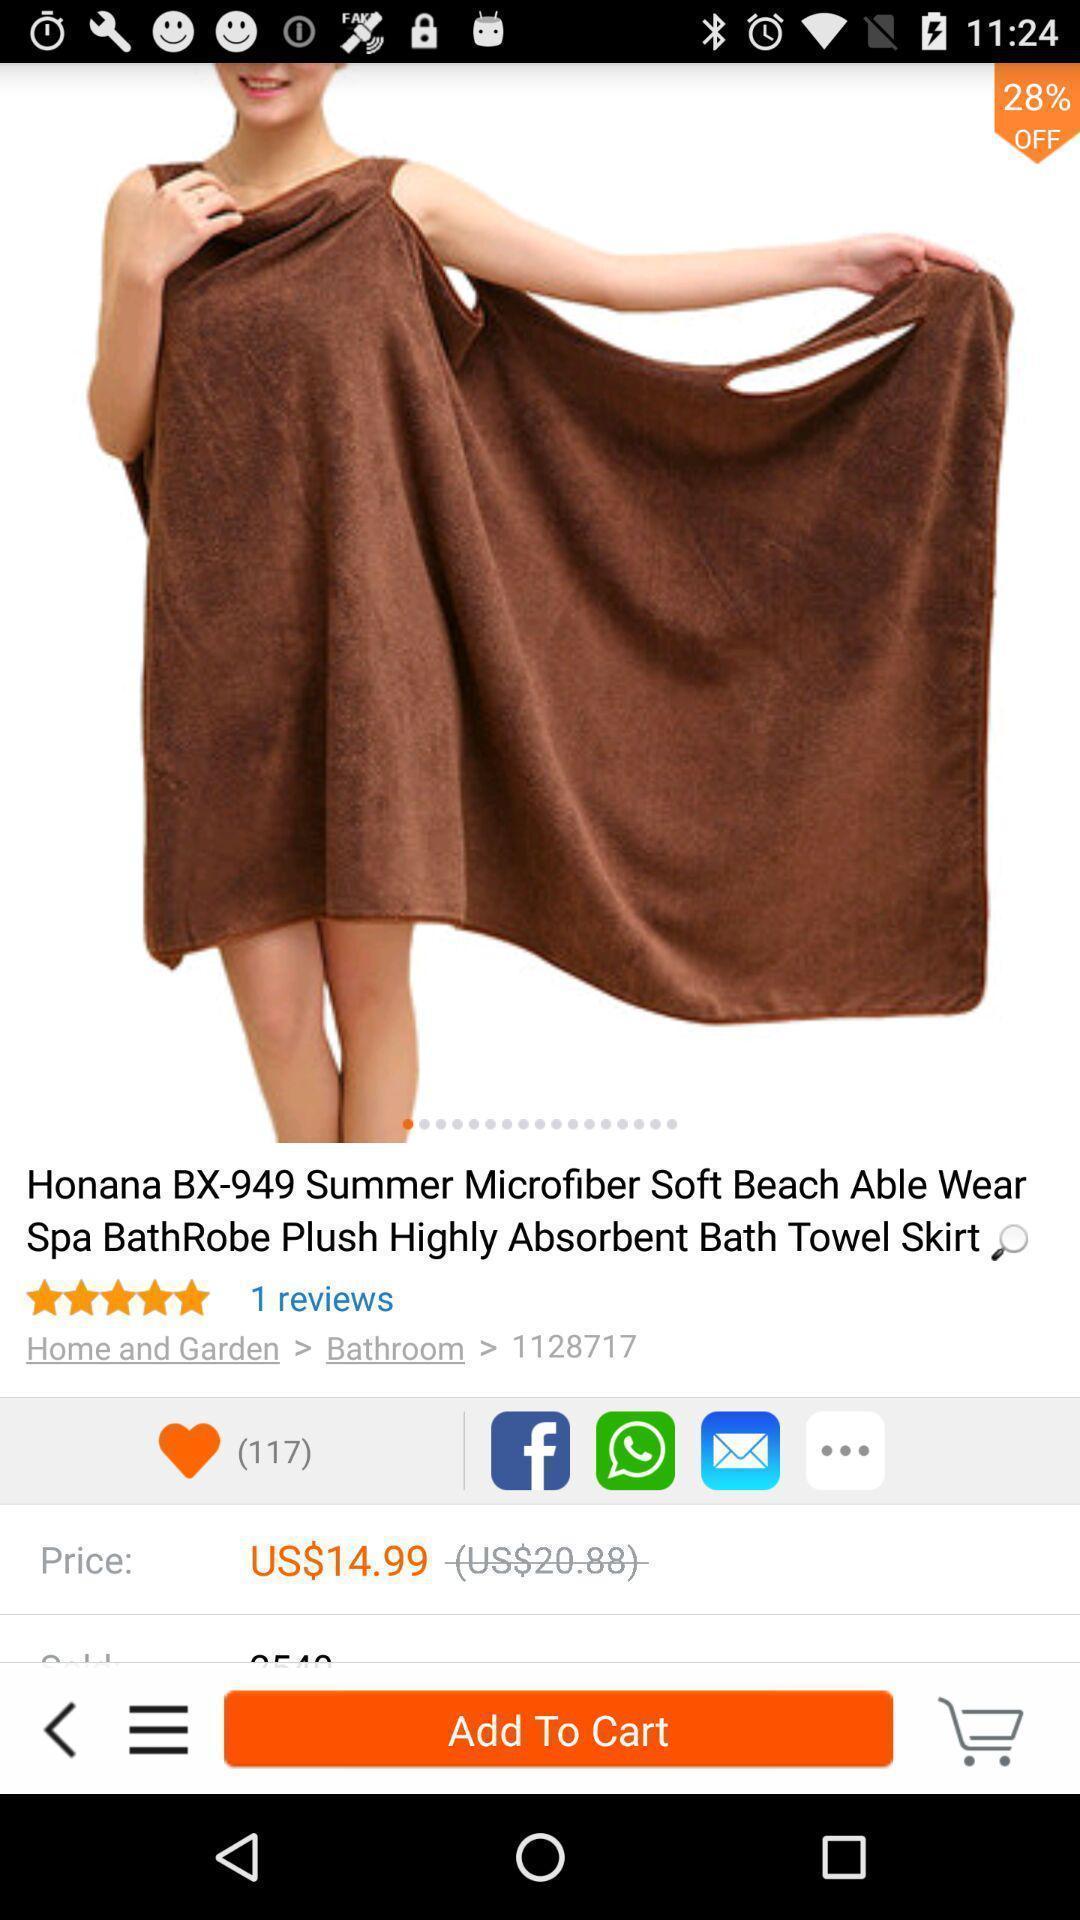Explain what's happening in this screen capture. Screen showing showing page of e commerce website. 